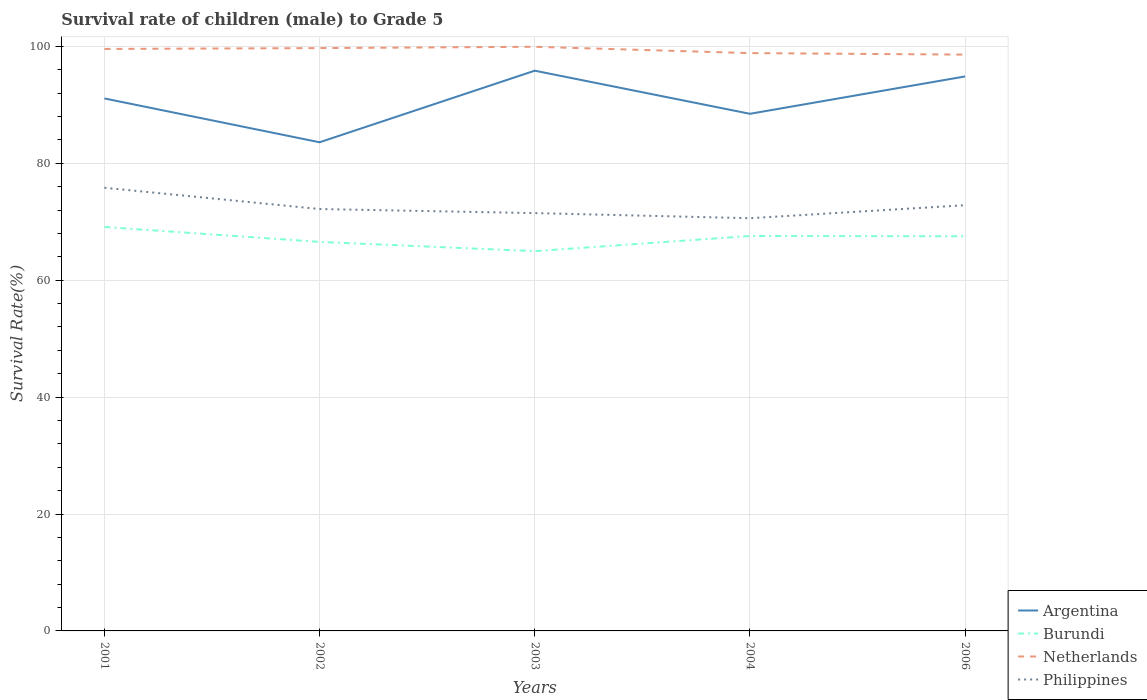How many different coloured lines are there?
Provide a short and direct response. 4. Does the line corresponding to Burundi intersect with the line corresponding to Netherlands?
Your answer should be compact. No. Is the number of lines equal to the number of legend labels?
Keep it short and to the point. Yes. Across all years, what is the maximum survival rate of male children to grade 5 in Burundi?
Your response must be concise. 64.96. What is the total survival rate of male children to grade 5 in Argentina in the graph?
Your answer should be very brief. 0.98. What is the difference between the highest and the second highest survival rate of male children to grade 5 in Philippines?
Give a very brief answer. 5.21. Is the survival rate of male children to grade 5 in Burundi strictly greater than the survival rate of male children to grade 5 in Argentina over the years?
Provide a succinct answer. Yes. Does the graph contain grids?
Ensure brevity in your answer.  Yes. How are the legend labels stacked?
Offer a very short reply. Vertical. What is the title of the graph?
Your response must be concise. Survival rate of children (male) to Grade 5. Does "Tuvalu" appear as one of the legend labels in the graph?
Make the answer very short. No. What is the label or title of the Y-axis?
Offer a terse response. Survival Rate(%). What is the Survival Rate(%) in Argentina in 2001?
Provide a short and direct response. 91.09. What is the Survival Rate(%) in Burundi in 2001?
Your response must be concise. 69.1. What is the Survival Rate(%) in Netherlands in 2001?
Your answer should be compact. 99.55. What is the Survival Rate(%) of Philippines in 2001?
Keep it short and to the point. 75.81. What is the Survival Rate(%) in Argentina in 2002?
Keep it short and to the point. 83.59. What is the Survival Rate(%) in Burundi in 2002?
Provide a succinct answer. 66.55. What is the Survival Rate(%) in Netherlands in 2002?
Offer a terse response. 99.7. What is the Survival Rate(%) of Philippines in 2002?
Provide a succinct answer. 72.17. What is the Survival Rate(%) in Argentina in 2003?
Provide a short and direct response. 95.84. What is the Survival Rate(%) of Burundi in 2003?
Your response must be concise. 64.96. What is the Survival Rate(%) of Netherlands in 2003?
Give a very brief answer. 99.92. What is the Survival Rate(%) in Philippines in 2003?
Provide a succinct answer. 71.48. What is the Survival Rate(%) of Argentina in 2004?
Make the answer very short. 88.46. What is the Survival Rate(%) in Burundi in 2004?
Make the answer very short. 67.56. What is the Survival Rate(%) in Netherlands in 2004?
Offer a terse response. 98.85. What is the Survival Rate(%) in Philippines in 2004?
Your response must be concise. 70.6. What is the Survival Rate(%) of Argentina in 2006?
Offer a terse response. 94.85. What is the Survival Rate(%) in Burundi in 2006?
Ensure brevity in your answer.  67.5. What is the Survival Rate(%) of Netherlands in 2006?
Your response must be concise. 98.59. What is the Survival Rate(%) of Philippines in 2006?
Offer a terse response. 72.83. Across all years, what is the maximum Survival Rate(%) of Argentina?
Offer a terse response. 95.84. Across all years, what is the maximum Survival Rate(%) in Burundi?
Your response must be concise. 69.1. Across all years, what is the maximum Survival Rate(%) in Netherlands?
Provide a short and direct response. 99.92. Across all years, what is the maximum Survival Rate(%) of Philippines?
Give a very brief answer. 75.81. Across all years, what is the minimum Survival Rate(%) of Argentina?
Ensure brevity in your answer.  83.59. Across all years, what is the minimum Survival Rate(%) in Burundi?
Offer a terse response. 64.96. Across all years, what is the minimum Survival Rate(%) in Netherlands?
Your answer should be compact. 98.59. Across all years, what is the minimum Survival Rate(%) of Philippines?
Provide a short and direct response. 70.6. What is the total Survival Rate(%) in Argentina in the graph?
Offer a very short reply. 453.83. What is the total Survival Rate(%) in Burundi in the graph?
Your response must be concise. 335.68. What is the total Survival Rate(%) of Netherlands in the graph?
Ensure brevity in your answer.  496.61. What is the total Survival Rate(%) of Philippines in the graph?
Provide a succinct answer. 362.88. What is the difference between the Survival Rate(%) in Argentina in 2001 and that in 2002?
Ensure brevity in your answer.  7.5. What is the difference between the Survival Rate(%) of Burundi in 2001 and that in 2002?
Ensure brevity in your answer.  2.56. What is the difference between the Survival Rate(%) of Netherlands in 2001 and that in 2002?
Ensure brevity in your answer.  -0.15. What is the difference between the Survival Rate(%) in Philippines in 2001 and that in 2002?
Ensure brevity in your answer.  3.64. What is the difference between the Survival Rate(%) of Argentina in 2001 and that in 2003?
Provide a short and direct response. -4.75. What is the difference between the Survival Rate(%) of Burundi in 2001 and that in 2003?
Your answer should be very brief. 4.14. What is the difference between the Survival Rate(%) of Netherlands in 2001 and that in 2003?
Keep it short and to the point. -0.37. What is the difference between the Survival Rate(%) in Philippines in 2001 and that in 2003?
Make the answer very short. 4.33. What is the difference between the Survival Rate(%) of Argentina in 2001 and that in 2004?
Offer a very short reply. 2.62. What is the difference between the Survival Rate(%) of Burundi in 2001 and that in 2004?
Give a very brief answer. 1.54. What is the difference between the Survival Rate(%) in Netherlands in 2001 and that in 2004?
Ensure brevity in your answer.  0.71. What is the difference between the Survival Rate(%) of Philippines in 2001 and that in 2004?
Provide a succinct answer. 5.21. What is the difference between the Survival Rate(%) of Argentina in 2001 and that in 2006?
Your response must be concise. -3.77. What is the difference between the Survival Rate(%) of Burundi in 2001 and that in 2006?
Your answer should be very brief. 1.6. What is the difference between the Survival Rate(%) of Netherlands in 2001 and that in 2006?
Provide a short and direct response. 0.97. What is the difference between the Survival Rate(%) of Philippines in 2001 and that in 2006?
Offer a very short reply. 2.99. What is the difference between the Survival Rate(%) of Argentina in 2002 and that in 2003?
Offer a terse response. -12.25. What is the difference between the Survival Rate(%) in Burundi in 2002 and that in 2003?
Your answer should be compact. 1.58. What is the difference between the Survival Rate(%) of Netherlands in 2002 and that in 2003?
Offer a very short reply. -0.22. What is the difference between the Survival Rate(%) of Philippines in 2002 and that in 2003?
Offer a very short reply. 0.69. What is the difference between the Survival Rate(%) in Argentina in 2002 and that in 2004?
Your response must be concise. -4.87. What is the difference between the Survival Rate(%) in Burundi in 2002 and that in 2004?
Offer a terse response. -1.01. What is the difference between the Survival Rate(%) in Netherlands in 2002 and that in 2004?
Your response must be concise. 0.85. What is the difference between the Survival Rate(%) in Philippines in 2002 and that in 2004?
Give a very brief answer. 1.57. What is the difference between the Survival Rate(%) in Argentina in 2002 and that in 2006?
Your answer should be compact. -11.26. What is the difference between the Survival Rate(%) in Burundi in 2002 and that in 2006?
Keep it short and to the point. -0.96. What is the difference between the Survival Rate(%) in Netherlands in 2002 and that in 2006?
Your answer should be compact. 1.12. What is the difference between the Survival Rate(%) in Philippines in 2002 and that in 2006?
Provide a succinct answer. -0.66. What is the difference between the Survival Rate(%) in Argentina in 2003 and that in 2004?
Offer a terse response. 7.37. What is the difference between the Survival Rate(%) in Burundi in 2003 and that in 2004?
Offer a very short reply. -2.6. What is the difference between the Survival Rate(%) in Netherlands in 2003 and that in 2004?
Provide a succinct answer. 1.08. What is the difference between the Survival Rate(%) of Philippines in 2003 and that in 2004?
Offer a terse response. 0.88. What is the difference between the Survival Rate(%) in Argentina in 2003 and that in 2006?
Your answer should be very brief. 0.98. What is the difference between the Survival Rate(%) in Burundi in 2003 and that in 2006?
Provide a succinct answer. -2.54. What is the difference between the Survival Rate(%) of Netherlands in 2003 and that in 2006?
Provide a succinct answer. 1.34. What is the difference between the Survival Rate(%) of Philippines in 2003 and that in 2006?
Your answer should be very brief. -1.35. What is the difference between the Survival Rate(%) in Argentina in 2004 and that in 2006?
Make the answer very short. -6.39. What is the difference between the Survival Rate(%) in Burundi in 2004 and that in 2006?
Offer a terse response. 0.06. What is the difference between the Survival Rate(%) of Netherlands in 2004 and that in 2006?
Make the answer very short. 0.26. What is the difference between the Survival Rate(%) of Philippines in 2004 and that in 2006?
Make the answer very short. -2.22. What is the difference between the Survival Rate(%) of Argentina in 2001 and the Survival Rate(%) of Burundi in 2002?
Offer a terse response. 24.54. What is the difference between the Survival Rate(%) of Argentina in 2001 and the Survival Rate(%) of Netherlands in 2002?
Your answer should be very brief. -8.61. What is the difference between the Survival Rate(%) of Argentina in 2001 and the Survival Rate(%) of Philippines in 2002?
Keep it short and to the point. 18.92. What is the difference between the Survival Rate(%) of Burundi in 2001 and the Survival Rate(%) of Netherlands in 2002?
Keep it short and to the point. -30.6. What is the difference between the Survival Rate(%) of Burundi in 2001 and the Survival Rate(%) of Philippines in 2002?
Provide a short and direct response. -3.07. What is the difference between the Survival Rate(%) in Netherlands in 2001 and the Survival Rate(%) in Philippines in 2002?
Your answer should be very brief. 27.38. What is the difference between the Survival Rate(%) in Argentina in 2001 and the Survival Rate(%) in Burundi in 2003?
Offer a very short reply. 26.12. What is the difference between the Survival Rate(%) of Argentina in 2001 and the Survival Rate(%) of Netherlands in 2003?
Provide a short and direct response. -8.84. What is the difference between the Survival Rate(%) in Argentina in 2001 and the Survival Rate(%) in Philippines in 2003?
Offer a very short reply. 19.61. What is the difference between the Survival Rate(%) in Burundi in 2001 and the Survival Rate(%) in Netherlands in 2003?
Provide a succinct answer. -30.82. What is the difference between the Survival Rate(%) of Burundi in 2001 and the Survival Rate(%) of Philippines in 2003?
Offer a terse response. -2.37. What is the difference between the Survival Rate(%) in Netherlands in 2001 and the Survival Rate(%) in Philippines in 2003?
Your answer should be compact. 28.08. What is the difference between the Survival Rate(%) of Argentina in 2001 and the Survival Rate(%) of Burundi in 2004?
Ensure brevity in your answer.  23.53. What is the difference between the Survival Rate(%) of Argentina in 2001 and the Survival Rate(%) of Netherlands in 2004?
Provide a succinct answer. -7.76. What is the difference between the Survival Rate(%) in Argentina in 2001 and the Survival Rate(%) in Philippines in 2004?
Provide a short and direct response. 20.49. What is the difference between the Survival Rate(%) in Burundi in 2001 and the Survival Rate(%) in Netherlands in 2004?
Ensure brevity in your answer.  -29.74. What is the difference between the Survival Rate(%) in Burundi in 2001 and the Survival Rate(%) in Philippines in 2004?
Your answer should be very brief. -1.5. What is the difference between the Survival Rate(%) in Netherlands in 2001 and the Survival Rate(%) in Philippines in 2004?
Your answer should be very brief. 28.95. What is the difference between the Survival Rate(%) in Argentina in 2001 and the Survival Rate(%) in Burundi in 2006?
Your answer should be compact. 23.58. What is the difference between the Survival Rate(%) of Argentina in 2001 and the Survival Rate(%) of Netherlands in 2006?
Give a very brief answer. -7.5. What is the difference between the Survival Rate(%) in Argentina in 2001 and the Survival Rate(%) in Philippines in 2006?
Your answer should be compact. 18.26. What is the difference between the Survival Rate(%) of Burundi in 2001 and the Survival Rate(%) of Netherlands in 2006?
Provide a succinct answer. -29.48. What is the difference between the Survival Rate(%) of Burundi in 2001 and the Survival Rate(%) of Philippines in 2006?
Provide a succinct answer. -3.72. What is the difference between the Survival Rate(%) of Netherlands in 2001 and the Survival Rate(%) of Philippines in 2006?
Keep it short and to the point. 26.73. What is the difference between the Survival Rate(%) in Argentina in 2002 and the Survival Rate(%) in Burundi in 2003?
Offer a very short reply. 18.63. What is the difference between the Survival Rate(%) in Argentina in 2002 and the Survival Rate(%) in Netherlands in 2003?
Provide a succinct answer. -16.33. What is the difference between the Survival Rate(%) in Argentina in 2002 and the Survival Rate(%) in Philippines in 2003?
Provide a short and direct response. 12.11. What is the difference between the Survival Rate(%) of Burundi in 2002 and the Survival Rate(%) of Netherlands in 2003?
Your answer should be very brief. -33.38. What is the difference between the Survival Rate(%) in Burundi in 2002 and the Survival Rate(%) in Philippines in 2003?
Give a very brief answer. -4.93. What is the difference between the Survival Rate(%) of Netherlands in 2002 and the Survival Rate(%) of Philippines in 2003?
Your answer should be very brief. 28.22. What is the difference between the Survival Rate(%) in Argentina in 2002 and the Survival Rate(%) in Burundi in 2004?
Make the answer very short. 16.03. What is the difference between the Survival Rate(%) in Argentina in 2002 and the Survival Rate(%) in Netherlands in 2004?
Your answer should be very brief. -15.26. What is the difference between the Survival Rate(%) in Argentina in 2002 and the Survival Rate(%) in Philippines in 2004?
Offer a terse response. 12.99. What is the difference between the Survival Rate(%) of Burundi in 2002 and the Survival Rate(%) of Netherlands in 2004?
Make the answer very short. -32.3. What is the difference between the Survival Rate(%) in Burundi in 2002 and the Survival Rate(%) in Philippines in 2004?
Your answer should be very brief. -4.05. What is the difference between the Survival Rate(%) in Netherlands in 2002 and the Survival Rate(%) in Philippines in 2004?
Ensure brevity in your answer.  29.1. What is the difference between the Survival Rate(%) of Argentina in 2002 and the Survival Rate(%) of Burundi in 2006?
Make the answer very short. 16.09. What is the difference between the Survival Rate(%) of Argentina in 2002 and the Survival Rate(%) of Netherlands in 2006?
Provide a succinct answer. -14.99. What is the difference between the Survival Rate(%) of Argentina in 2002 and the Survival Rate(%) of Philippines in 2006?
Your answer should be very brief. 10.77. What is the difference between the Survival Rate(%) in Burundi in 2002 and the Survival Rate(%) in Netherlands in 2006?
Give a very brief answer. -32.04. What is the difference between the Survival Rate(%) of Burundi in 2002 and the Survival Rate(%) of Philippines in 2006?
Ensure brevity in your answer.  -6.28. What is the difference between the Survival Rate(%) of Netherlands in 2002 and the Survival Rate(%) of Philippines in 2006?
Give a very brief answer. 26.88. What is the difference between the Survival Rate(%) of Argentina in 2003 and the Survival Rate(%) of Burundi in 2004?
Give a very brief answer. 28.28. What is the difference between the Survival Rate(%) of Argentina in 2003 and the Survival Rate(%) of Netherlands in 2004?
Provide a succinct answer. -3.01. What is the difference between the Survival Rate(%) in Argentina in 2003 and the Survival Rate(%) in Philippines in 2004?
Offer a terse response. 25.24. What is the difference between the Survival Rate(%) of Burundi in 2003 and the Survival Rate(%) of Netherlands in 2004?
Your answer should be very brief. -33.88. What is the difference between the Survival Rate(%) in Burundi in 2003 and the Survival Rate(%) in Philippines in 2004?
Ensure brevity in your answer.  -5.64. What is the difference between the Survival Rate(%) of Netherlands in 2003 and the Survival Rate(%) of Philippines in 2004?
Provide a succinct answer. 29.32. What is the difference between the Survival Rate(%) of Argentina in 2003 and the Survival Rate(%) of Burundi in 2006?
Give a very brief answer. 28.33. What is the difference between the Survival Rate(%) of Argentina in 2003 and the Survival Rate(%) of Netherlands in 2006?
Your answer should be compact. -2.75. What is the difference between the Survival Rate(%) of Argentina in 2003 and the Survival Rate(%) of Philippines in 2006?
Keep it short and to the point. 23.01. What is the difference between the Survival Rate(%) of Burundi in 2003 and the Survival Rate(%) of Netherlands in 2006?
Make the answer very short. -33.62. What is the difference between the Survival Rate(%) of Burundi in 2003 and the Survival Rate(%) of Philippines in 2006?
Your answer should be compact. -7.86. What is the difference between the Survival Rate(%) in Netherlands in 2003 and the Survival Rate(%) in Philippines in 2006?
Give a very brief answer. 27.1. What is the difference between the Survival Rate(%) in Argentina in 2004 and the Survival Rate(%) in Burundi in 2006?
Your answer should be compact. 20.96. What is the difference between the Survival Rate(%) in Argentina in 2004 and the Survival Rate(%) in Netherlands in 2006?
Provide a short and direct response. -10.12. What is the difference between the Survival Rate(%) in Argentina in 2004 and the Survival Rate(%) in Philippines in 2006?
Provide a succinct answer. 15.64. What is the difference between the Survival Rate(%) of Burundi in 2004 and the Survival Rate(%) of Netherlands in 2006?
Ensure brevity in your answer.  -31.03. What is the difference between the Survival Rate(%) of Burundi in 2004 and the Survival Rate(%) of Philippines in 2006?
Your answer should be very brief. -5.26. What is the difference between the Survival Rate(%) of Netherlands in 2004 and the Survival Rate(%) of Philippines in 2006?
Provide a short and direct response. 26.02. What is the average Survival Rate(%) in Argentina per year?
Offer a terse response. 90.77. What is the average Survival Rate(%) of Burundi per year?
Provide a succinct answer. 67.14. What is the average Survival Rate(%) in Netherlands per year?
Your answer should be compact. 99.32. What is the average Survival Rate(%) in Philippines per year?
Ensure brevity in your answer.  72.58. In the year 2001, what is the difference between the Survival Rate(%) in Argentina and Survival Rate(%) in Burundi?
Offer a very short reply. 21.98. In the year 2001, what is the difference between the Survival Rate(%) in Argentina and Survival Rate(%) in Netherlands?
Make the answer very short. -8.47. In the year 2001, what is the difference between the Survival Rate(%) in Argentina and Survival Rate(%) in Philippines?
Offer a very short reply. 15.28. In the year 2001, what is the difference between the Survival Rate(%) of Burundi and Survival Rate(%) of Netherlands?
Your answer should be very brief. -30.45. In the year 2001, what is the difference between the Survival Rate(%) in Burundi and Survival Rate(%) in Philippines?
Offer a terse response. -6.71. In the year 2001, what is the difference between the Survival Rate(%) in Netherlands and Survival Rate(%) in Philippines?
Provide a succinct answer. 23.74. In the year 2002, what is the difference between the Survival Rate(%) in Argentina and Survival Rate(%) in Burundi?
Provide a short and direct response. 17.04. In the year 2002, what is the difference between the Survival Rate(%) of Argentina and Survival Rate(%) of Netherlands?
Make the answer very short. -16.11. In the year 2002, what is the difference between the Survival Rate(%) of Argentina and Survival Rate(%) of Philippines?
Provide a succinct answer. 11.42. In the year 2002, what is the difference between the Survival Rate(%) in Burundi and Survival Rate(%) in Netherlands?
Your answer should be compact. -33.15. In the year 2002, what is the difference between the Survival Rate(%) of Burundi and Survival Rate(%) of Philippines?
Give a very brief answer. -5.62. In the year 2002, what is the difference between the Survival Rate(%) of Netherlands and Survival Rate(%) of Philippines?
Keep it short and to the point. 27.53. In the year 2003, what is the difference between the Survival Rate(%) in Argentina and Survival Rate(%) in Burundi?
Offer a very short reply. 30.87. In the year 2003, what is the difference between the Survival Rate(%) in Argentina and Survival Rate(%) in Netherlands?
Your answer should be very brief. -4.09. In the year 2003, what is the difference between the Survival Rate(%) of Argentina and Survival Rate(%) of Philippines?
Your answer should be very brief. 24.36. In the year 2003, what is the difference between the Survival Rate(%) of Burundi and Survival Rate(%) of Netherlands?
Your answer should be compact. -34.96. In the year 2003, what is the difference between the Survival Rate(%) in Burundi and Survival Rate(%) in Philippines?
Give a very brief answer. -6.51. In the year 2003, what is the difference between the Survival Rate(%) in Netherlands and Survival Rate(%) in Philippines?
Your answer should be compact. 28.45. In the year 2004, what is the difference between the Survival Rate(%) in Argentina and Survival Rate(%) in Burundi?
Provide a succinct answer. 20.9. In the year 2004, what is the difference between the Survival Rate(%) of Argentina and Survival Rate(%) of Netherlands?
Offer a very short reply. -10.38. In the year 2004, what is the difference between the Survival Rate(%) in Argentina and Survival Rate(%) in Philippines?
Your response must be concise. 17.86. In the year 2004, what is the difference between the Survival Rate(%) in Burundi and Survival Rate(%) in Netherlands?
Provide a short and direct response. -31.29. In the year 2004, what is the difference between the Survival Rate(%) of Burundi and Survival Rate(%) of Philippines?
Provide a succinct answer. -3.04. In the year 2004, what is the difference between the Survival Rate(%) in Netherlands and Survival Rate(%) in Philippines?
Offer a very short reply. 28.25. In the year 2006, what is the difference between the Survival Rate(%) in Argentina and Survival Rate(%) in Burundi?
Ensure brevity in your answer.  27.35. In the year 2006, what is the difference between the Survival Rate(%) of Argentina and Survival Rate(%) of Netherlands?
Ensure brevity in your answer.  -3.73. In the year 2006, what is the difference between the Survival Rate(%) in Argentina and Survival Rate(%) in Philippines?
Ensure brevity in your answer.  22.03. In the year 2006, what is the difference between the Survival Rate(%) of Burundi and Survival Rate(%) of Netherlands?
Provide a short and direct response. -31.08. In the year 2006, what is the difference between the Survival Rate(%) of Burundi and Survival Rate(%) of Philippines?
Make the answer very short. -5.32. In the year 2006, what is the difference between the Survival Rate(%) in Netherlands and Survival Rate(%) in Philippines?
Provide a short and direct response. 25.76. What is the ratio of the Survival Rate(%) of Argentina in 2001 to that in 2002?
Give a very brief answer. 1.09. What is the ratio of the Survival Rate(%) in Burundi in 2001 to that in 2002?
Your answer should be very brief. 1.04. What is the ratio of the Survival Rate(%) of Netherlands in 2001 to that in 2002?
Provide a short and direct response. 1. What is the ratio of the Survival Rate(%) in Philippines in 2001 to that in 2002?
Make the answer very short. 1.05. What is the ratio of the Survival Rate(%) in Argentina in 2001 to that in 2003?
Keep it short and to the point. 0.95. What is the ratio of the Survival Rate(%) in Burundi in 2001 to that in 2003?
Offer a terse response. 1.06. What is the ratio of the Survival Rate(%) of Netherlands in 2001 to that in 2003?
Offer a very short reply. 1. What is the ratio of the Survival Rate(%) of Philippines in 2001 to that in 2003?
Provide a succinct answer. 1.06. What is the ratio of the Survival Rate(%) of Argentina in 2001 to that in 2004?
Offer a very short reply. 1.03. What is the ratio of the Survival Rate(%) in Burundi in 2001 to that in 2004?
Your response must be concise. 1.02. What is the ratio of the Survival Rate(%) in Netherlands in 2001 to that in 2004?
Keep it short and to the point. 1.01. What is the ratio of the Survival Rate(%) in Philippines in 2001 to that in 2004?
Provide a succinct answer. 1.07. What is the ratio of the Survival Rate(%) in Argentina in 2001 to that in 2006?
Ensure brevity in your answer.  0.96. What is the ratio of the Survival Rate(%) in Burundi in 2001 to that in 2006?
Offer a terse response. 1.02. What is the ratio of the Survival Rate(%) in Netherlands in 2001 to that in 2006?
Make the answer very short. 1.01. What is the ratio of the Survival Rate(%) of Philippines in 2001 to that in 2006?
Ensure brevity in your answer.  1.04. What is the ratio of the Survival Rate(%) of Argentina in 2002 to that in 2003?
Offer a very short reply. 0.87. What is the ratio of the Survival Rate(%) in Burundi in 2002 to that in 2003?
Provide a succinct answer. 1.02. What is the ratio of the Survival Rate(%) in Netherlands in 2002 to that in 2003?
Your response must be concise. 1. What is the ratio of the Survival Rate(%) of Philippines in 2002 to that in 2003?
Offer a terse response. 1.01. What is the ratio of the Survival Rate(%) of Argentina in 2002 to that in 2004?
Ensure brevity in your answer.  0.94. What is the ratio of the Survival Rate(%) of Burundi in 2002 to that in 2004?
Keep it short and to the point. 0.98. What is the ratio of the Survival Rate(%) in Netherlands in 2002 to that in 2004?
Give a very brief answer. 1.01. What is the ratio of the Survival Rate(%) in Philippines in 2002 to that in 2004?
Provide a short and direct response. 1.02. What is the ratio of the Survival Rate(%) in Argentina in 2002 to that in 2006?
Provide a succinct answer. 0.88. What is the ratio of the Survival Rate(%) in Burundi in 2002 to that in 2006?
Your answer should be compact. 0.99. What is the ratio of the Survival Rate(%) in Netherlands in 2002 to that in 2006?
Your answer should be very brief. 1.01. What is the ratio of the Survival Rate(%) of Philippines in 2002 to that in 2006?
Make the answer very short. 0.99. What is the ratio of the Survival Rate(%) of Argentina in 2003 to that in 2004?
Offer a terse response. 1.08. What is the ratio of the Survival Rate(%) of Burundi in 2003 to that in 2004?
Offer a terse response. 0.96. What is the ratio of the Survival Rate(%) in Netherlands in 2003 to that in 2004?
Your answer should be compact. 1.01. What is the ratio of the Survival Rate(%) of Philippines in 2003 to that in 2004?
Your answer should be very brief. 1.01. What is the ratio of the Survival Rate(%) in Argentina in 2003 to that in 2006?
Provide a succinct answer. 1.01. What is the ratio of the Survival Rate(%) of Burundi in 2003 to that in 2006?
Your answer should be compact. 0.96. What is the ratio of the Survival Rate(%) of Netherlands in 2003 to that in 2006?
Offer a very short reply. 1.01. What is the ratio of the Survival Rate(%) in Philippines in 2003 to that in 2006?
Provide a short and direct response. 0.98. What is the ratio of the Survival Rate(%) in Argentina in 2004 to that in 2006?
Your answer should be compact. 0.93. What is the ratio of the Survival Rate(%) of Burundi in 2004 to that in 2006?
Your answer should be very brief. 1. What is the ratio of the Survival Rate(%) of Philippines in 2004 to that in 2006?
Your answer should be very brief. 0.97. What is the difference between the highest and the second highest Survival Rate(%) in Argentina?
Your response must be concise. 0.98. What is the difference between the highest and the second highest Survival Rate(%) in Burundi?
Provide a short and direct response. 1.54. What is the difference between the highest and the second highest Survival Rate(%) of Netherlands?
Your response must be concise. 0.22. What is the difference between the highest and the second highest Survival Rate(%) of Philippines?
Provide a succinct answer. 2.99. What is the difference between the highest and the lowest Survival Rate(%) of Argentina?
Give a very brief answer. 12.25. What is the difference between the highest and the lowest Survival Rate(%) of Burundi?
Ensure brevity in your answer.  4.14. What is the difference between the highest and the lowest Survival Rate(%) of Netherlands?
Offer a terse response. 1.34. What is the difference between the highest and the lowest Survival Rate(%) in Philippines?
Provide a short and direct response. 5.21. 